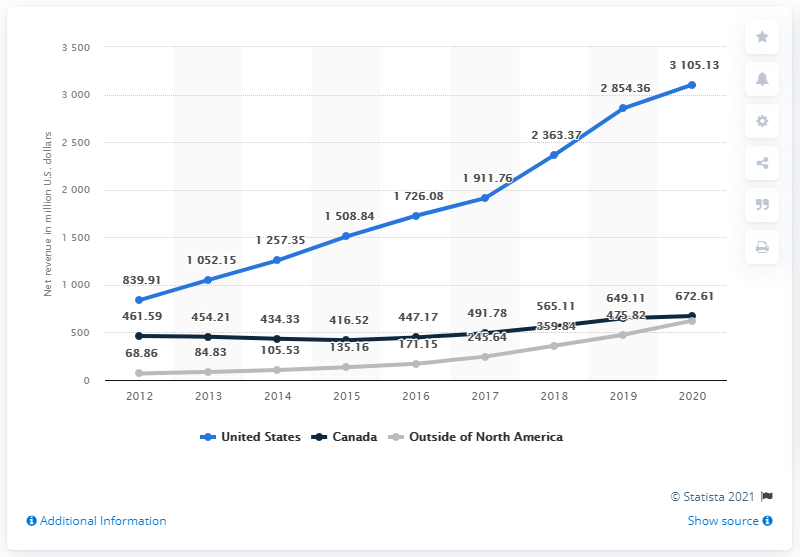Give some essential details in this illustration. Lululemon's net revenue from regions outside of North America was 624.14 million. The revenue difference between the highest value in the United States and the lowest value in Canada is 2643.54. The color used to represent the United States in the chart is blue. 